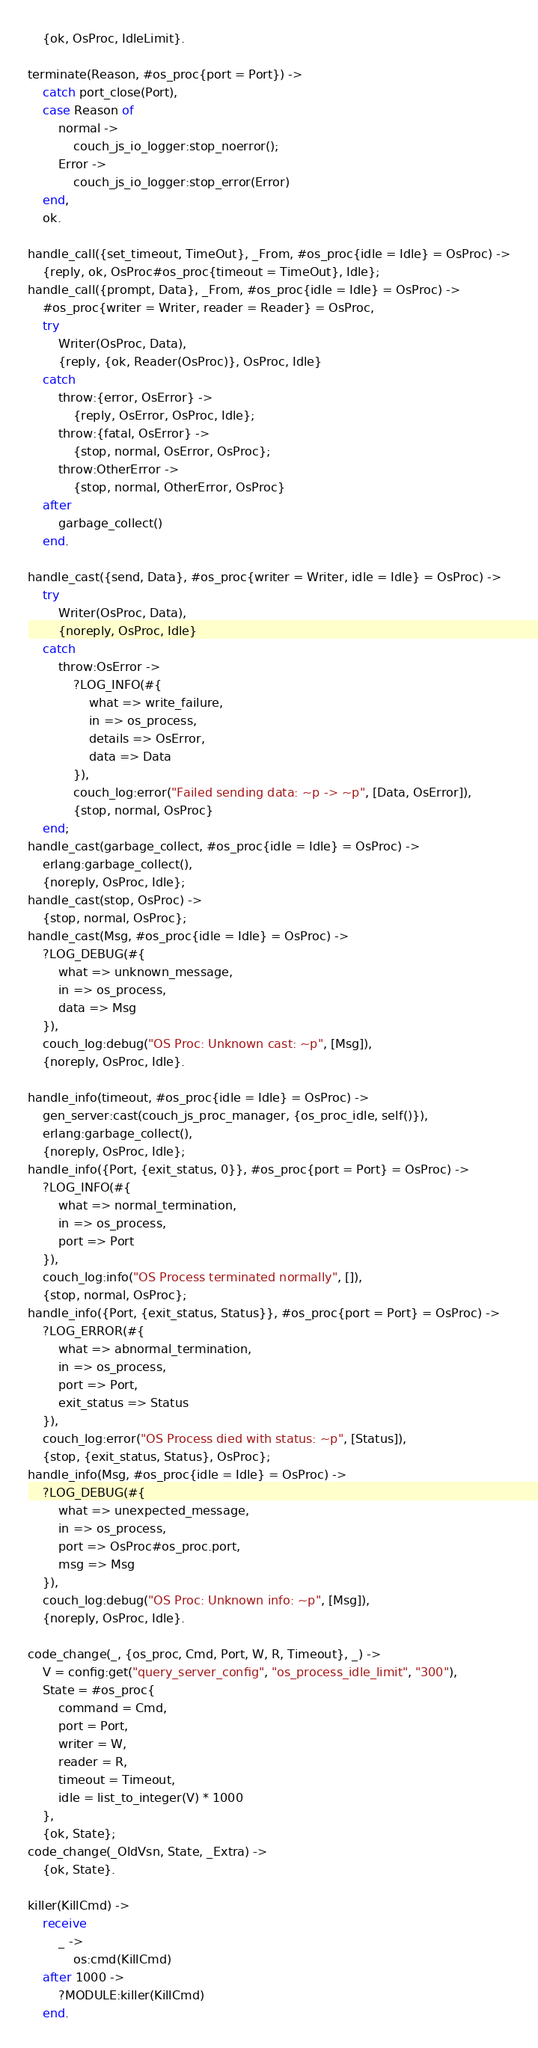<code> <loc_0><loc_0><loc_500><loc_500><_Erlang_>    {ok, OsProc, IdleLimit}.

terminate(Reason, #os_proc{port = Port}) ->
    catch port_close(Port),
    case Reason of
        normal ->
            couch_js_io_logger:stop_noerror();
        Error ->
            couch_js_io_logger:stop_error(Error)
    end,
    ok.

handle_call({set_timeout, TimeOut}, _From, #os_proc{idle = Idle} = OsProc) ->
    {reply, ok, OsProc#os_proc{timeout = TimeOut}, Idle};
handle_call({prompt, Data}, _From, #os_proc{idle = Idle} = OsProc) ->
    #os_proc{writer = Writer, reader = Reader} = OsProc,
    try
        Writer(OsProc, Data),
        {reply, {ok, Reader(OsProc)}, OsProc, Idle}
    catch
        throw:{error, OsError} ->
            {reply, OsError, OsProc, Idle};
        throw:{fatal, OsError} ->
            {stop, normal, OsError, OsProc};
        throw:OtherError ->
            {stop, normal, OtherError, OsProc}
    after
        garbage_collect()
    end.

handle_cast({send, Data}, #os_proc{writer = Writer, idle = Idle} = OsProc) ->
    try
        Writer(OsProc, Data),
        {noreply, OsProc, Idle}
    catch
        throw:OsError ->
            ?LOG_INFO(#{
                what => write_failure,
                in => os_process,
                details => OsError,
                data => Data
            }),
            couch_log:error("Failed sending data: ~p -> ~p", [Data, OsError]),
            {stop, normal, OsProc}
    end;
handle_cast(garbage_collect, #os_proc{idle = Idle} = OsProc) ->
    erlang:garbage_collect(),
    {noreply, OsProc, Idle};
handle_cast(stop, OsProc) ->
    {stop, normal, OsProc};
handle_cast(Msg, #os_proc{idle = Idle} = OsProc) ->
    ?LOG_DEBUG(#{
        what => unknown_message,
        in => os_process,
        data => Msg
    }),
    couch_log:debug("OS Proc: Unknown cast: ~p", [Msg]),
    {noreply, OsProc, Idle}.

handle_info(timeout, #os_proc{idle = Idle} = OsProc) ->
    gen_server:cast(couch_js_proc_manager, {os_proc_idle, self()}),
    erlang:garbage_collect(),
    {noreply, OsProc, Idle};
handle_info({Port, {exit_status, 0}}, #os_proc{port = Port} = OsProc) ->
    ?LOG_INFO(#{
        what => normal_termination,
        in => os_process,
        port => Port
    }),
    couch_log:info("OS Process terminated normally", []),
    {stop, normal, OsProc};
handle_info({Port, {exit_status, Status}}, #os_proc{port = Port} = OsProc) ->
    ?LOG_ERROR(#{
        what => abnormal_termination,
        in => os_process,
        port => Port,
        exit_status => Status
    }),
    couch_log:error("OS Process died with status: ~p", [Status]),
    {stop, {exit_status, Status}, OsProc};
handle_info(Msg, #os_proc{idle = Idle} = OsProc) ->
    ?LOG_DEBUG(#{
        what => unexpected_message,
        in => os_process,
        port => OsProc#os_proc.port,
        msg => Msg
    }),
    couch_log:debug("OS Proc: Unknown info: ~p", [Msg]),
    {noreply, OsProc, Idle}.

code_change(_, {os_proc, Cmd, Port, W, R, Timeout}, _) ->
    V = config:get("query_server_config", "os_process_idle_limit", "300"),
    State = #os_proc{
        command = Cmd,
        port = Port,
        writer = W,
        reader = R,
        timeout = Timeout,
        idle = list_to_integer(V) * 1000
    },
    {ok, State};
code_change(_OldVsn, State, _Extra) ->
    {ok, State}.

killer(KillCmd) ->
    receive
        _ ->
            os:cmd(KillCmd)
    after 1000 ->
        ?MODULE:killer(KillCmd)
    end.
</code> 